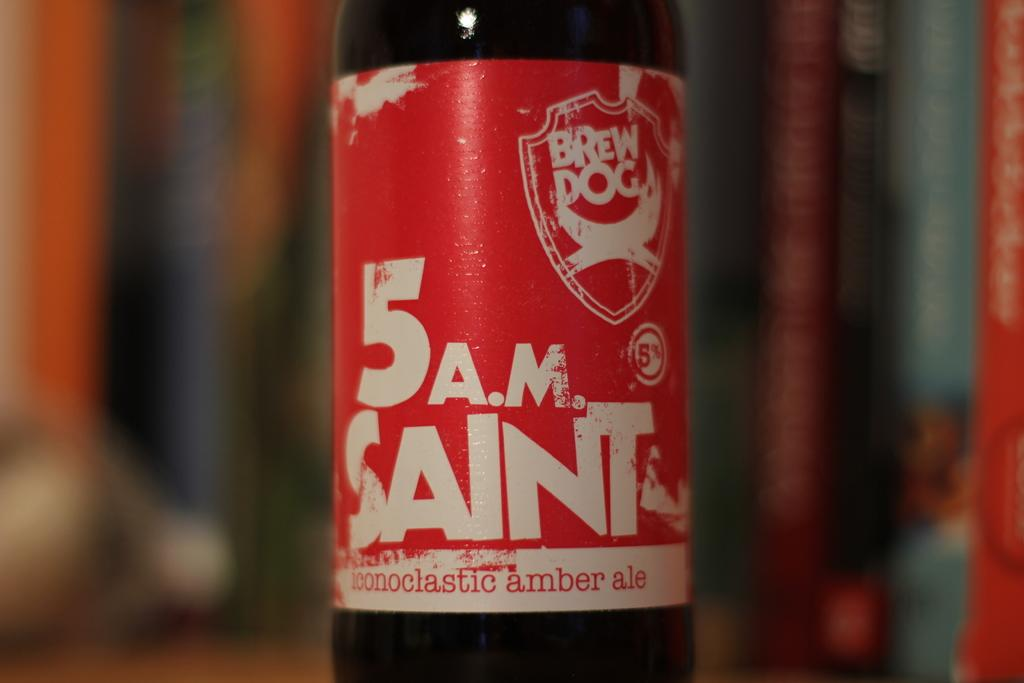What object is present in the image? There is a bottle in the image. What color is the label on the bottle? The label on the bottle is red. What can be found on the label? There is text written on the label. How would you describe the background of the image? The background of the image is blurry. What type of butter is being stored in the jar in the image? There is no jar or butter present in the image; it only features a bottle with a red label. Can you see a ray of light shining through the image? There is no mention of a ray of light in the provided facts, and therefore it cannot be confirmed or denied. 